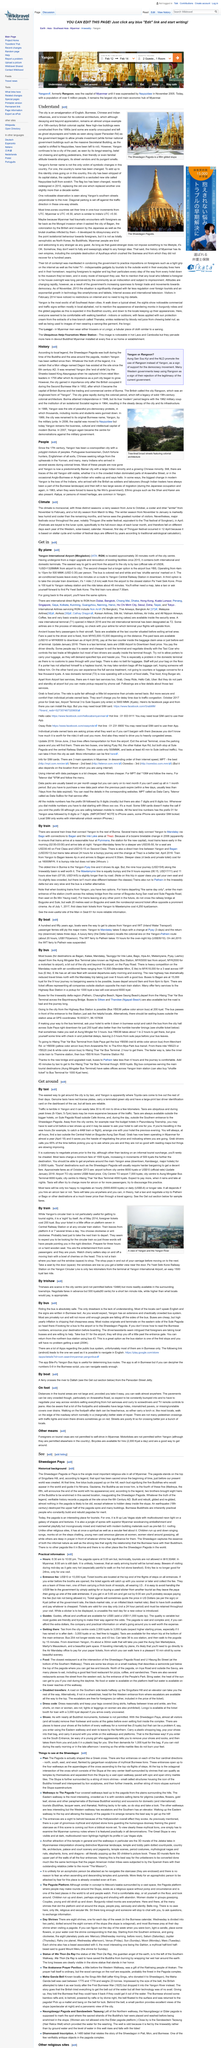Specify some key components in this picture. The pavements on Anwaratha Road are particularly crowded for those seeking to explore on foot. When navigating the streets of Yangon, it is common for traffic to last anywhere from 30 to 45 minutes to cover a relatively short distance. Vendors on Anwaratha Road sell a variety of food items, including hot samosas. Yangon International Airport is located approximately 30 minutes north of the city center, providing easy access to all travelers. The historical background of Shwedagon Paya is the focus of discussion in this article. 